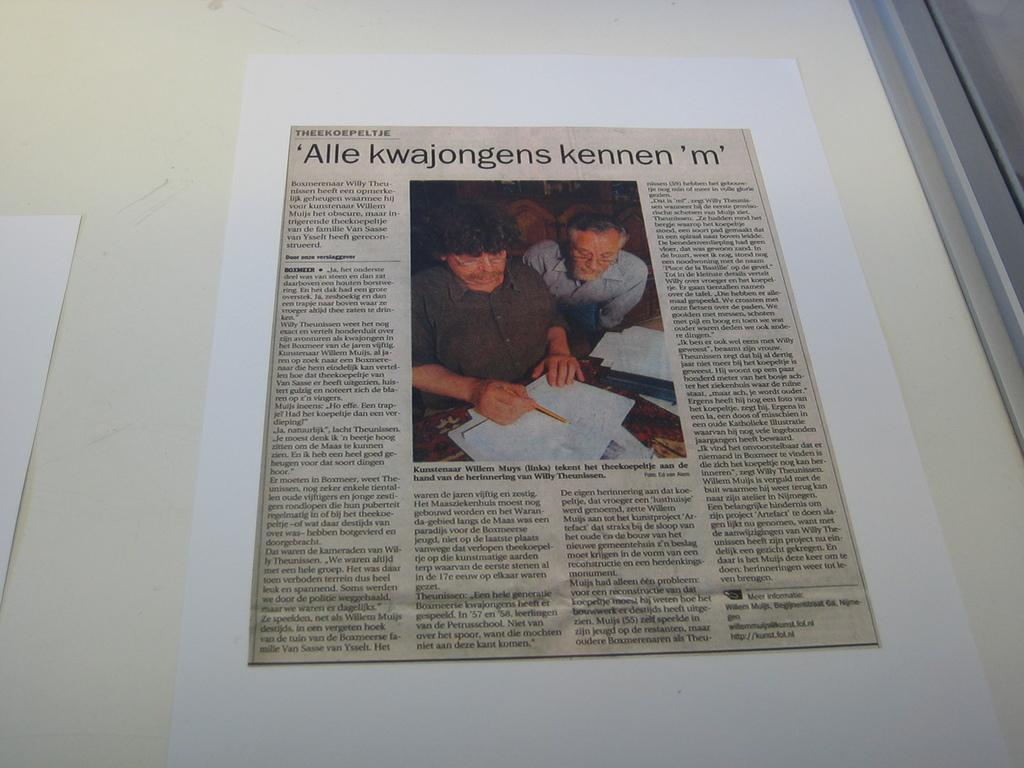What is attached to the wall in the image? There are papers attached to the wall in the image. Where can you find the best deals for groceries in the image? There is no reference to a market or grocery deals in the image, as it only features papers attached to the wall. 